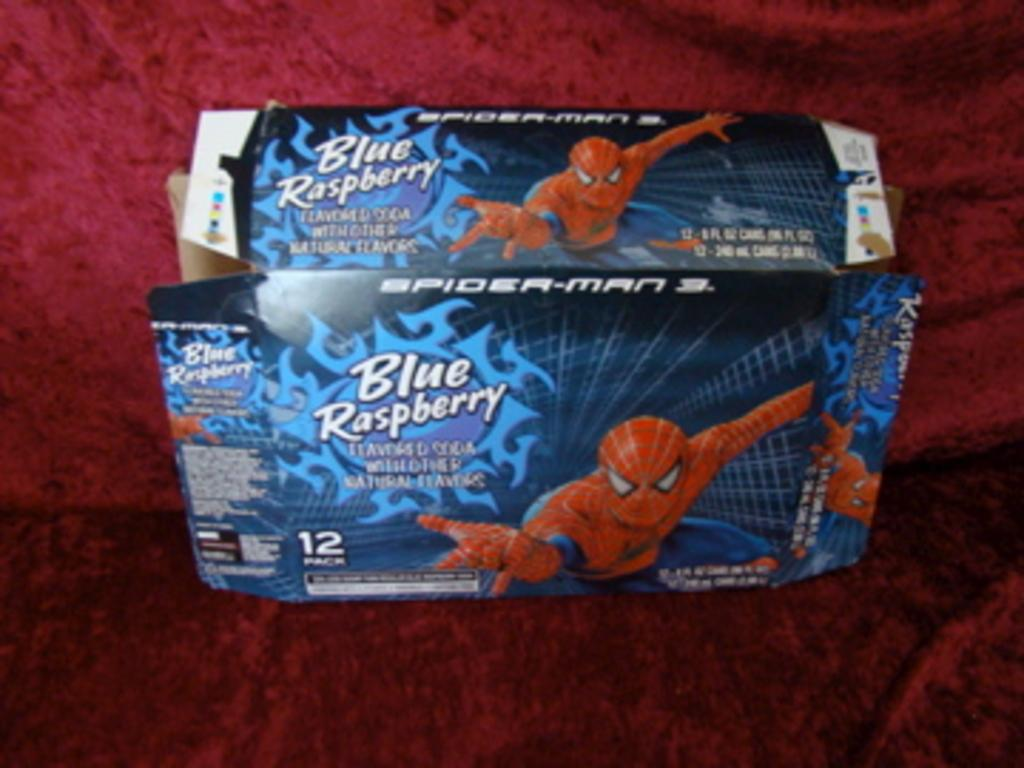What object is present in the image? There is a box in the image. Can you describe the surface on which the box is placed? The box is on a red color cloth. Can you see any windows in the image? There is no reference to a window in the image, so it is not possible to determine if any windows are visible. What type of metal is the watch made of in the image? There is no watch present in the image, so it is not possible to determine the type of metal it might be made of. 